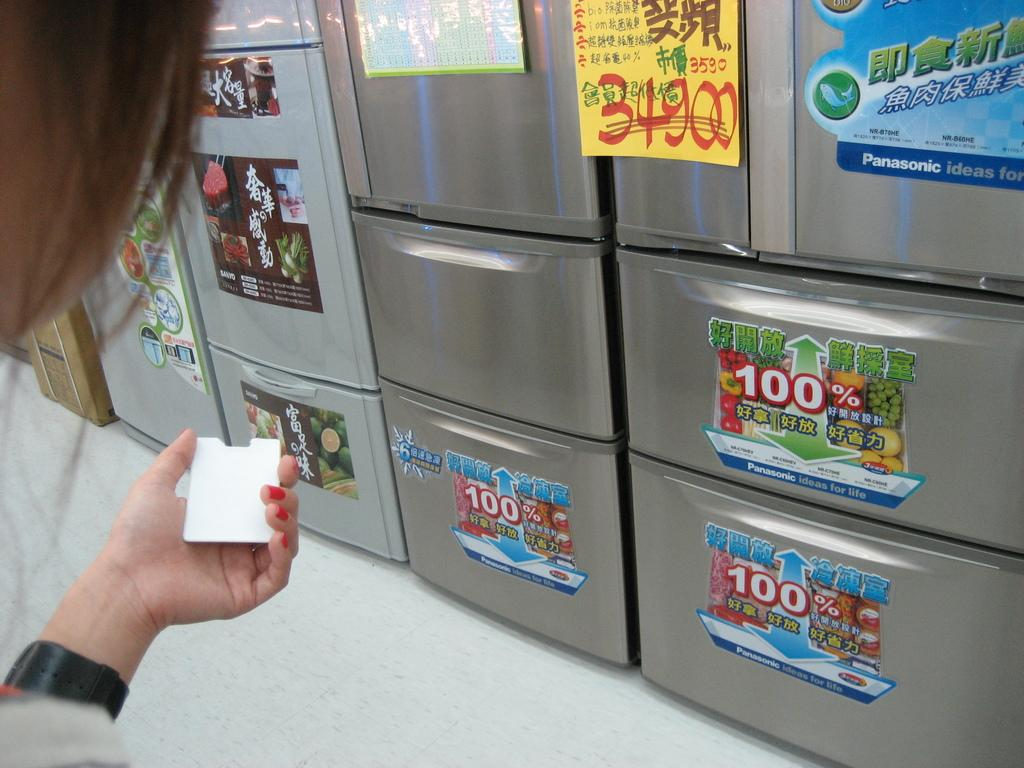Who or what is present in the image? There is a person in the image. What is the person holding in the image? The person is holding a white object. What type of surface is visible in the image? There is a floor visible in the image. Where are the posters located in the image? The posters are on a refrigerator in the image. What type of fuel is being used by the cord in the image? There is no cord or fuel present in the image. 